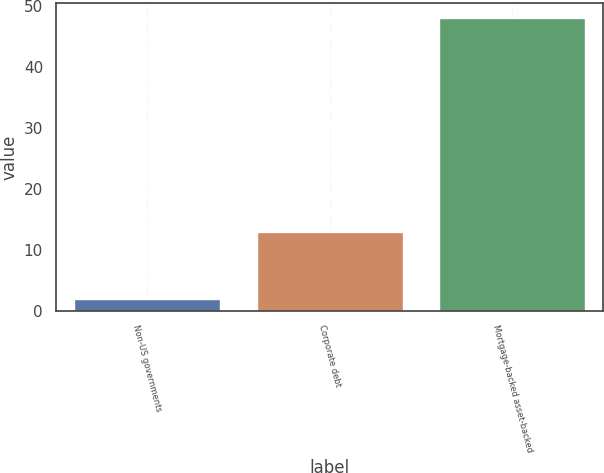Convert chart. <chart><loc_0><loc_0><loc_500><loc_500><bar_chart><fcel>Non-US governments<fcel>Corporate debt<fcel>Mortgage-backed asset-backed<nl><fcel>2<fcel>13<fcel>48<nl></chart> 